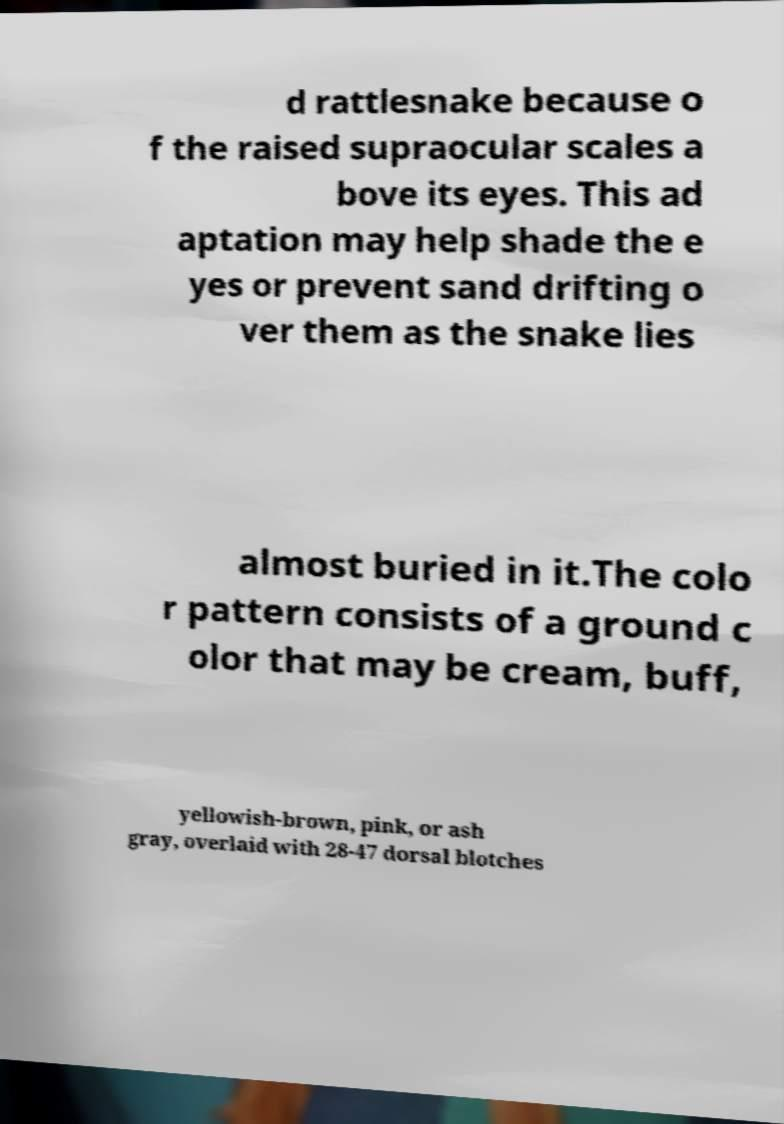I need the written content from this picture converted into text. Can you do that? d rattlesnake because o f the raised supraocular scales a bove its eyes. This ad aptation may help shade the e yes or prevent sand drifting o ver them as the snake lies almost buried in it.The colo r pattern consists of a ground c olor that may be cream, buff, yellowish-brown, pink, or ash gray, overlaid with 28-47 dorsal blotches 